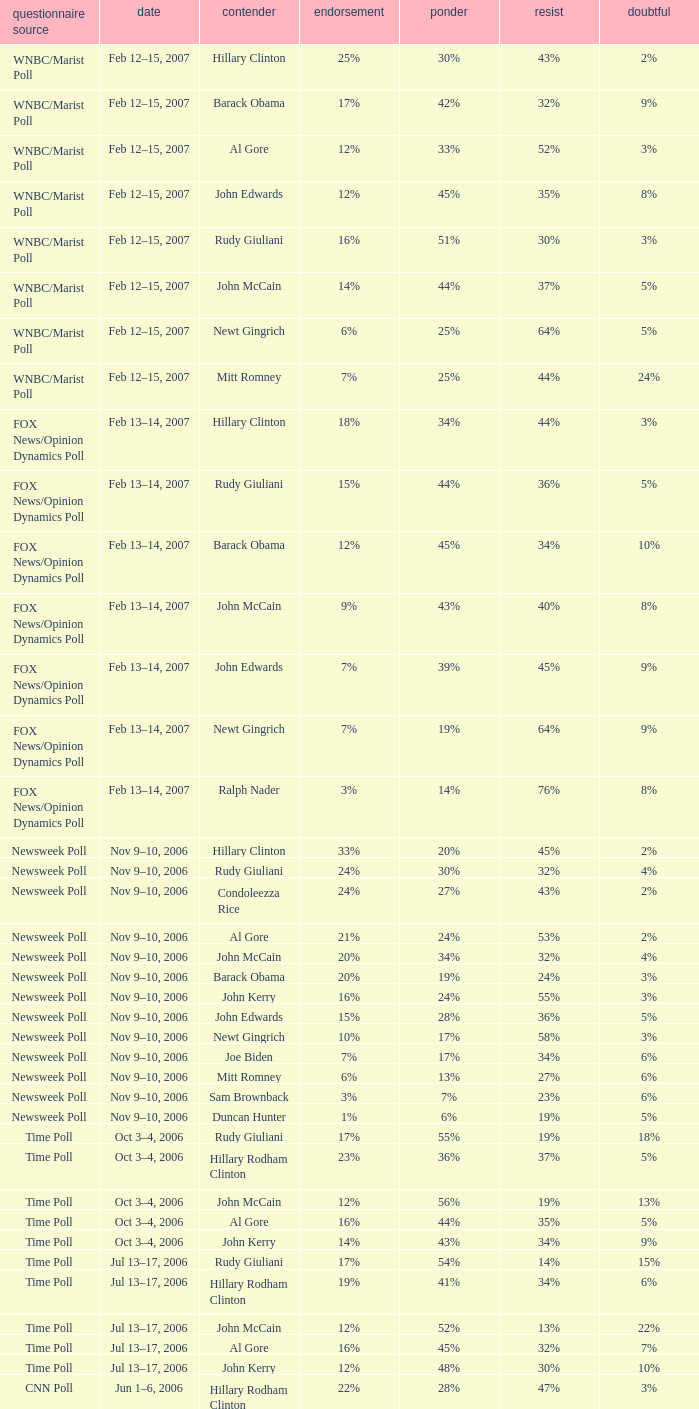What percentage of people said they would consider Rudy Giuliani as a candidate according to the Newsweek poll that showed 32% opposed him? 30%. 